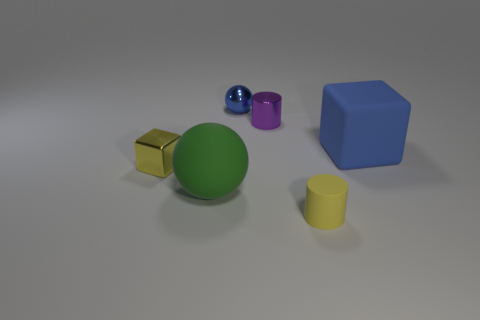The small metallic thing that is the same color as the rubber cylinder is what shape?
Provide a succinct answer. Cube. What is the size of the ball that is the same color as the large cube?
Give a very brief answer. Small. What number of other objects are the same size as the rubber cylinder?
Your answer should be compact. 3. There is a thing to the right of the yellow thing on the right side of the shiny thing that is in front of the big blue matte thing; what is its color?
Your answer should be very brief. Blue. How many other objects are there of the same shape as the yellow shiny thing?
Keep it short and to the point. 1. There is a shiny thing that is to the right of the blue sphere; what shape is it?
Give a very brief answer. Cylinder. There is a ball that is right of the green sphere; is there a small blue shiny object in front of it?
Keep it short and to the point. No. There is a thing that is behind the big rubber ball and left of the metal ball; what color is it?
Give a very brief answer. Yellow. There is a large matte thing that is to the right of the tiny cylinder that is in front of the large green rubber ball; is there a large rubber sphere that is behind it?
Ensure brevity in your answer.  No. The yellow rubber object that is the same shape as the purple metallic object is what size?
Your answer should be compact. Small. 